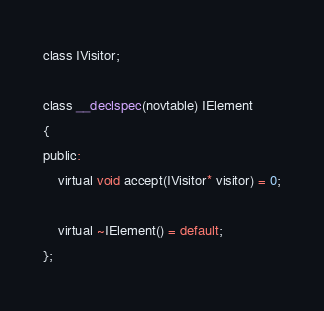<code> <loc_0><loc_0><loc_500><loc_500><_C_>class IVisitor;

class __declspec(novtable) IElement
{
public:
    virtual void accept(IVisitor* visitor) = 0;

    virtual ~IElement() = default;
};</code> 